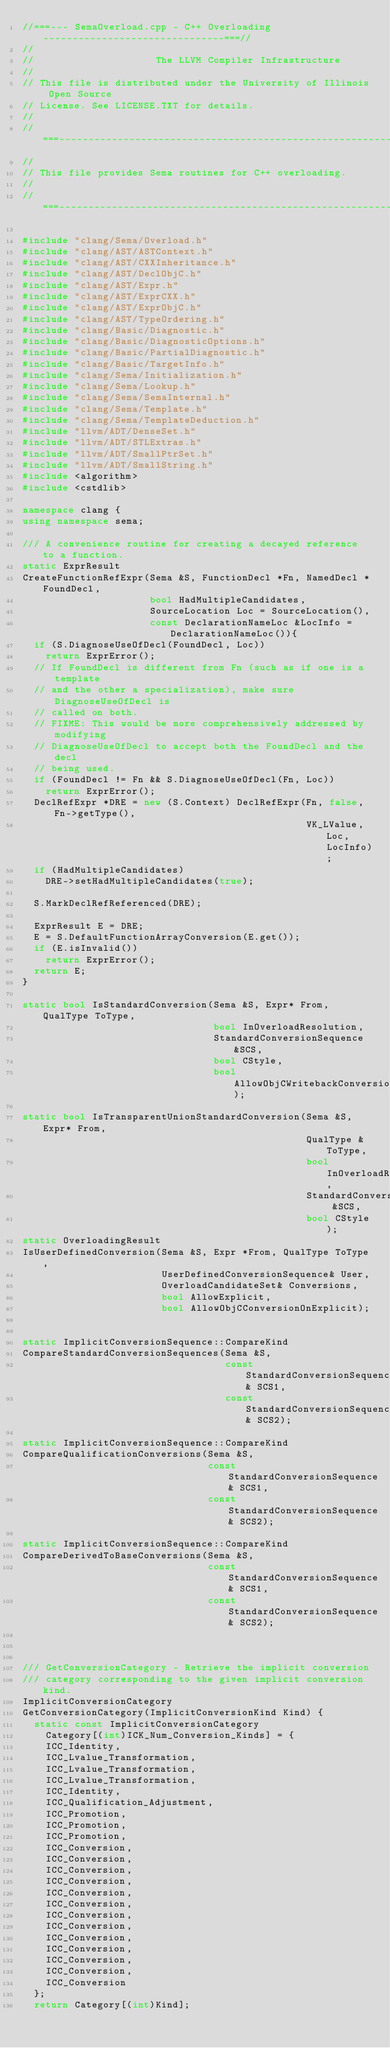<code> <loc_0><loc_0><loc_500><loc_500><_C++_>//===--- SemaOverload.cpp - C++ Overloading -------------------------------===//
//
//                     The LLVM Compiler Infrastructure
//
// This file is distributed under the University of Illinois Open Source
// License. See LICENSE.TXT for details.
//
//===----------------------------------------------------------------------===//
//
// This file provides Sema routines for C++ overloading.
//
//===----------------------------------------------------------------------===//

#include "clang/Sema/Overload.h"
#include "clang/AST/ASTContext.h"
#include "clang/AST/CXXInheritance.h"
#include "clang/AST/DeclObjC.h"
#include "clang/AST/Expr.h"
#include "clang/AST/ExprCXX.h"
#include "clang/AST/ExprObjC.h"
#include "clang/AST/TypeOrdering.h"
#include "clang/Basic/Diagnostic.h"
#include "clang/Basic/DiagnosticOptions.h"
#include "clang/Basic/PartialDiagnostic.h"
#include "clang/Basic/TargetInfo.h"
#include "clang/Sema/Initialization.h"
#include "clang/Sema/Lookup.h"
#include "clang/Sema/SemaInternal.h"
#include "clang/Sema/Template.h"
#include "clang/Sema/TemplateDeduction.h"
#include "llvm/ADT/DenseSet.h"
#include "llvm/ADT/STLExtras.h"
#include "llvm/ADT/SmallPtrSet.h"
#include "llvm/ADT/SmallString.h"
#include <algorithm>
#include <cstdlib>

namespace clang {
using namespace sema;

/// A convenience routine for creating a decayed reference to a function.
static ExprResult
CreateFunctionRefExpr(Sema &S, FunctionDecl *Fn, NamedDecl *FoundDecl,
                      bool HadMultipleCandidates,
                      SourceLocation Loc = SourceLocation(), 
                      const DeclarationNameLoc &LocInfo = DeclarationNameLoc()){
  if (S.DiagnoseUseOfDecl(FoundDecl, Loc))
    return ExprError(); 
  // If FoundDecl is different from Fn (such as if one is a template
  // and the other a specialization), make sure DiagnoseUseOfDecl is 
  // called on both.
  // FIXME: This would be more comprehensively addressed by modifying
  // DiagnoseUseOfDecl to accept both the FoundDecl and the decl
  // being used.
  if (FoundDecl != Fn && S.DiagnoseUseOfDecl(Fn, Loc))
    return ExprError();
  DeclRefExpr *DRE = new (S.Context) DeclRefExpr(Fn, false, Fn->getType(),
                                                 VK_LValue, Loc, LocInfo);
  if (HadMultipleCandidates)
    DRE->setHadMultipleCandidates(true);

  S.MarkDeclRefReferenced(DRE);

  ExprResult E = DRE;
  E = S.DefaultFunctionArrayConversion(E.get());
  if (E.isInvalid())
    return ExprError();
  return E;
}

static bool IsStandardConversion(Sema &S, Expr* From, QualType ToType,
                                 bool InOverloadResolution,
                                 StandardConversionSequence &SCS,
                                 bool CStyle,
                                 bool AllowObjCWritebackConversion);

static bool IsTransparentUnionStandardConversion(Sema &S, Expr* From, 
                                                 QualType &ToType,
                                                 bool InOverloadResolution,
                                                 StandardConversionSequence &SCS,
                                                 bool CStyle);
static OverloadingResult
IsUserDefinedConversion(Sema &S, Expr *From, QualType ToType,
                        UserDefinedConversionSequence& User,
                        OverloadCandidateSet& Conversions,
                        bool AllowExplicit,
                        bool AllowObjCConversionOnExplicit);


static ImplicitConversionSequence::CompareKind
CompareStandardConversionSequences(Sema &S,
                                   const StandardConversionSequence& SCS1,
                                   const StandardConversionSequence& SCS2);

static ImplicitConversionSequence::CompareKind
CompareQualificationConversions(Sema &S,
                                const StandardConversionSequence& SCS1,
                                const StandardConversionSequence& SCS2);

static ImplicitConversionSequence::CompareKind
CompareDerivedToBaseConversions(Sema &S,
                                const StandardConversionSequence& SCS1,
                                const StandardConversionSequence& SCS2);



/// GetConversionCategory - Retrieve the implicit conversion
/// category corresponding to the given implicit conversion kind.
ImplicitConversionCategory
GetConversionCategory(ImplicitConversionKind Kind) {
  static const ImplicitConversionCategory
    Category[(int)ICK_Num_Conversion_Kinds] = {
    ICC_Identity,
    ICC_Lvalue_Transformation,
    ICC_Lvalue_Transformation,
    ICC_Lvalue_Transformation,
    ICC_Identity,
    ICC_Qualification_Adjustment,
    ICC_Promotion,
    ICC_Promotion,
    ICC_Promotion,
    ICC_Conversion,
    ICC_Conversion,
    ICC_Conversion,
    ICC_Conversion,
    ICC_Conversion,
    ICC_Conversion,
    ICC_Conversion,
    ICC_Conversion,
    ICC_Conversion,
    ICC_Conversion,
    ICC_Conversion,
    ICC_Conversion,
    ICC_Conversion
  };
  return Category[(int)Kind];</code> 